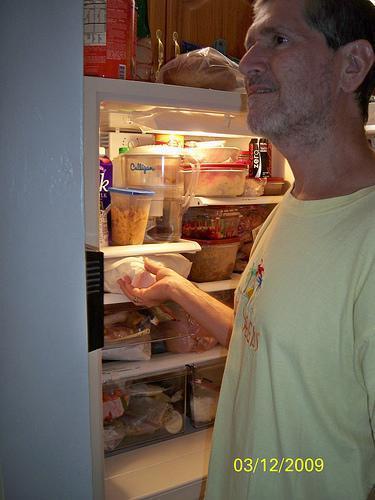How many men are there?
Give a very brief answer. 1. 